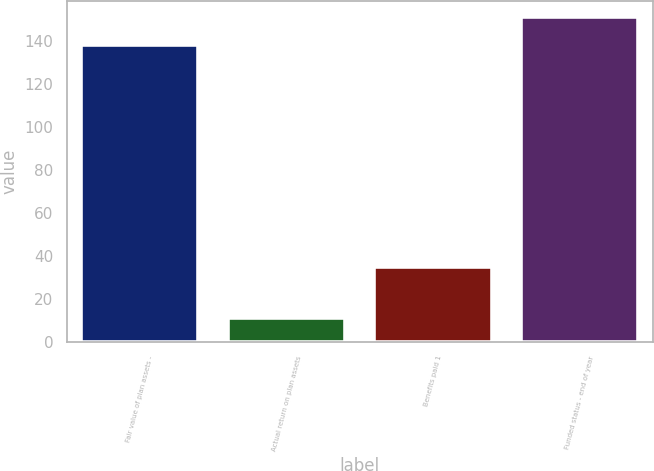<chart> <loc_0><loc_0><loc_500><loc_500><bar_chart><fcel>Fair value of plan assets -<fcel>Actual return on plan assets<fcel>Benefits paid 1<fcel>Funded status - end of year<nl><fcel>138<fcel>11<fcel>35<fcel>151.1<nl></chart> 